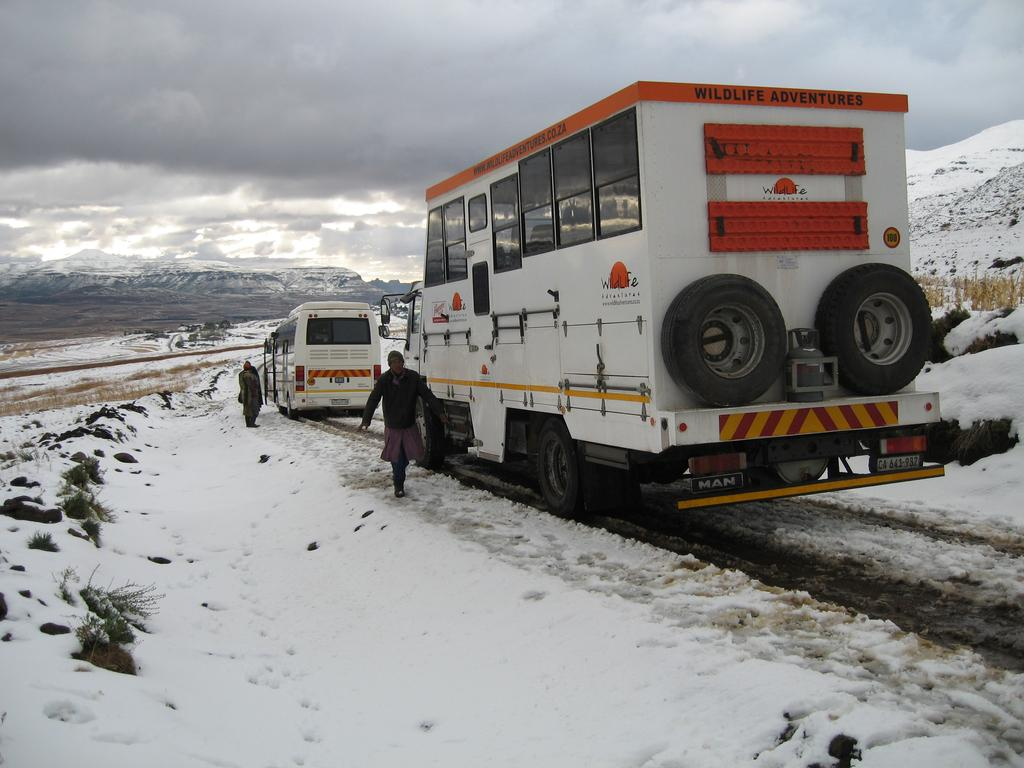How many vehicles are present in the image? There are two vehicles in the image. What else can be seen on the land in the image besides the vehicles? There are people on the land in the image. What is the condition of the land in the image? The land in the image has snow on it. What is visible at the top of the image? The sky is visible at the top of the image. How is the sky depicted in the image? The sky is covered with clouds in the image. Where is the grandfather sitting with the ducks in the image? There is no grandfather or ducks present in the image. What type of beetle can be seen crawling on the snow in the image? There are no beetles visible in the image; it only features vehicles, people, snow, and a cloudy sky. 